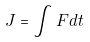Convert formula to latex. <formula><loc_0><loc_0><loc_500><loc_500>J = \int F d t</formula> 